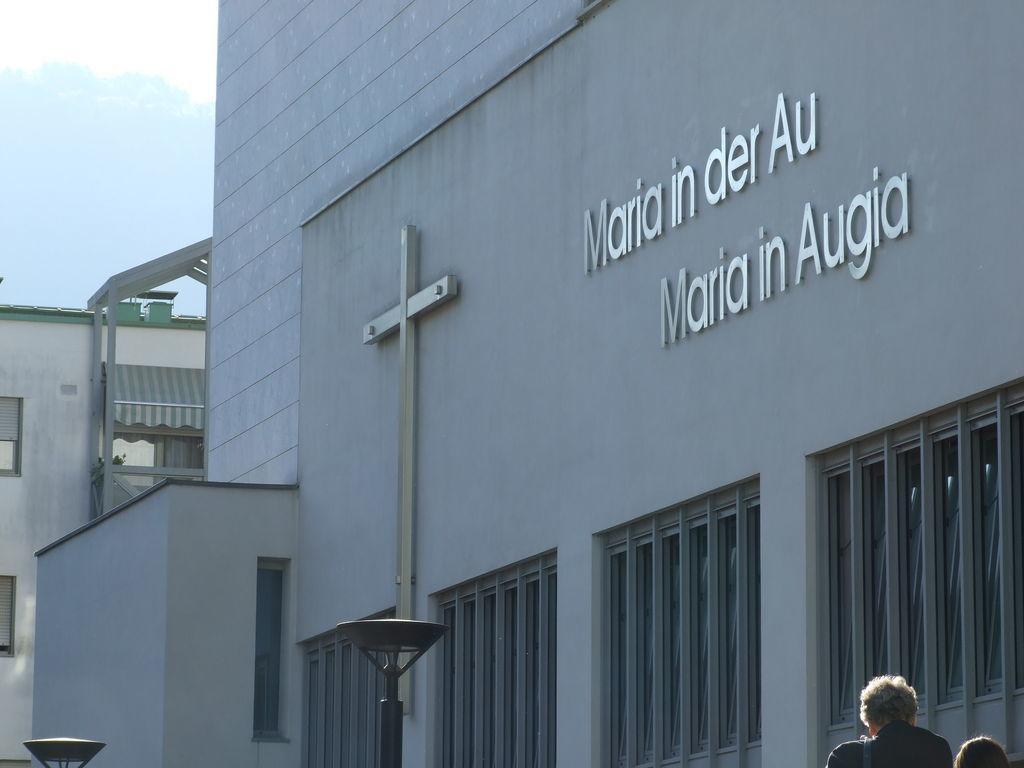In one or two sentences, can you explain what this image depicts? In this image we can see building with some text, light poles, people and windows. 